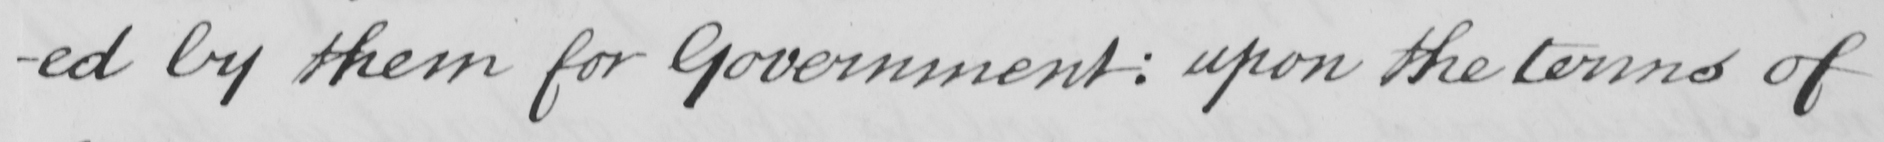Can you tell me what this handwritten text says? -ed by them for Government :  upon the terms of 